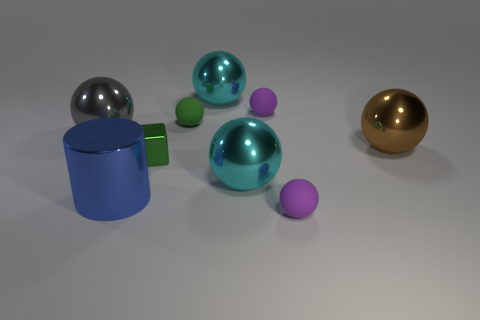Subtract all cyan balls. How many balls are left? 5 Subtract all green matte balls. How many balls are left? 6 Subtract all blue balls. Subtract all brown cylinders. How many balls are left? 7 Add 1 large gray balls. How many objects exist? 10 Subtract all blocks. How many objects are left? 8 Add 7 purple things. How many purple things exist? 9 Subtract 1 gray spheres. How many objects are left? 8 Subtract all small blue metallic cylinders. Subtract all large gray things. How many objects are left? 8 Add 3 big blue cylinders. How many big blue cylinders are left? 4 